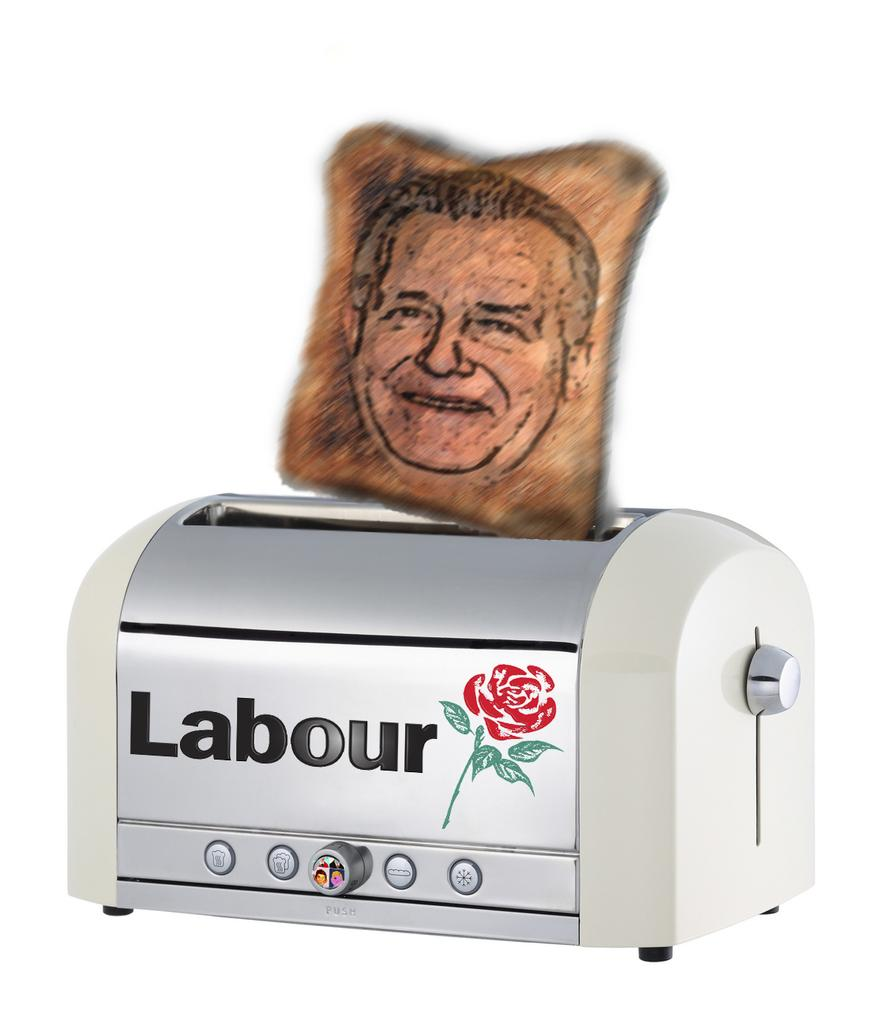What appliance is present in the image? There is a toaster in the image. What design is on the toaster? The toaster has a rose print on it. What food item is visible in the image? There is a toast in the image. What is unique about the toast? The toast has a print of a person's face on it. What is the color of the background in the image? The background in the image is white. Can you hear the family singing a song in the image? There is no reference to a family or singing in the image, so it is not possible to answer that question. 